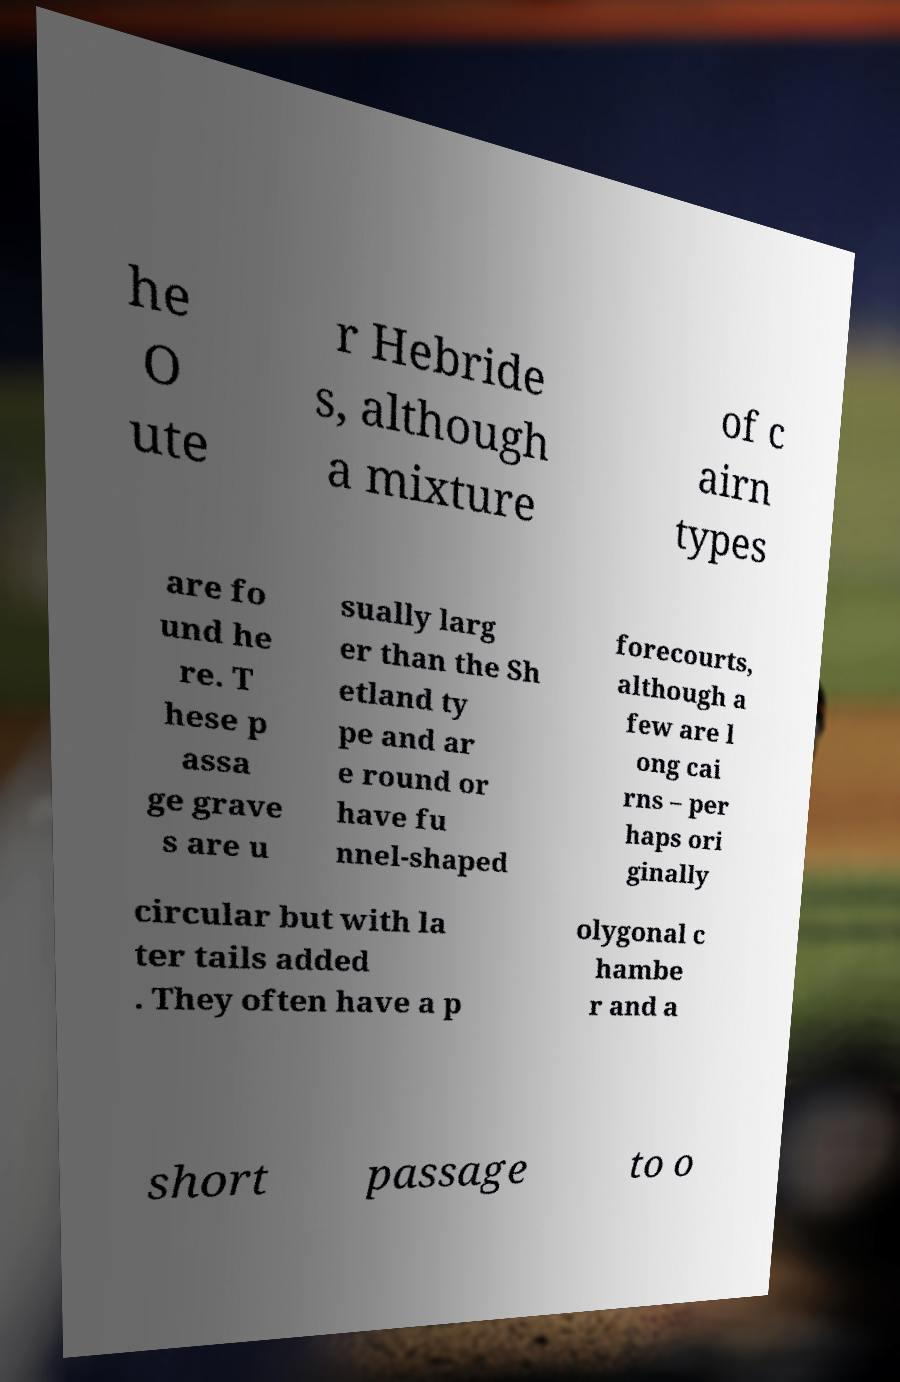I need the written content from this picture converted into text. Can you do that? he O ute r Hebride s, although a mixture of c airn types are fo und he re. T hese p assa ge grave s are u sually larg er than the Sh etland ty pe and ar e round or have fu nnel-shaped forecourts, although a few are l ong cai rns – per haps ori ginally circular but with la ter tails added . They often have a p olygonal c hambe r and a short passage to o 